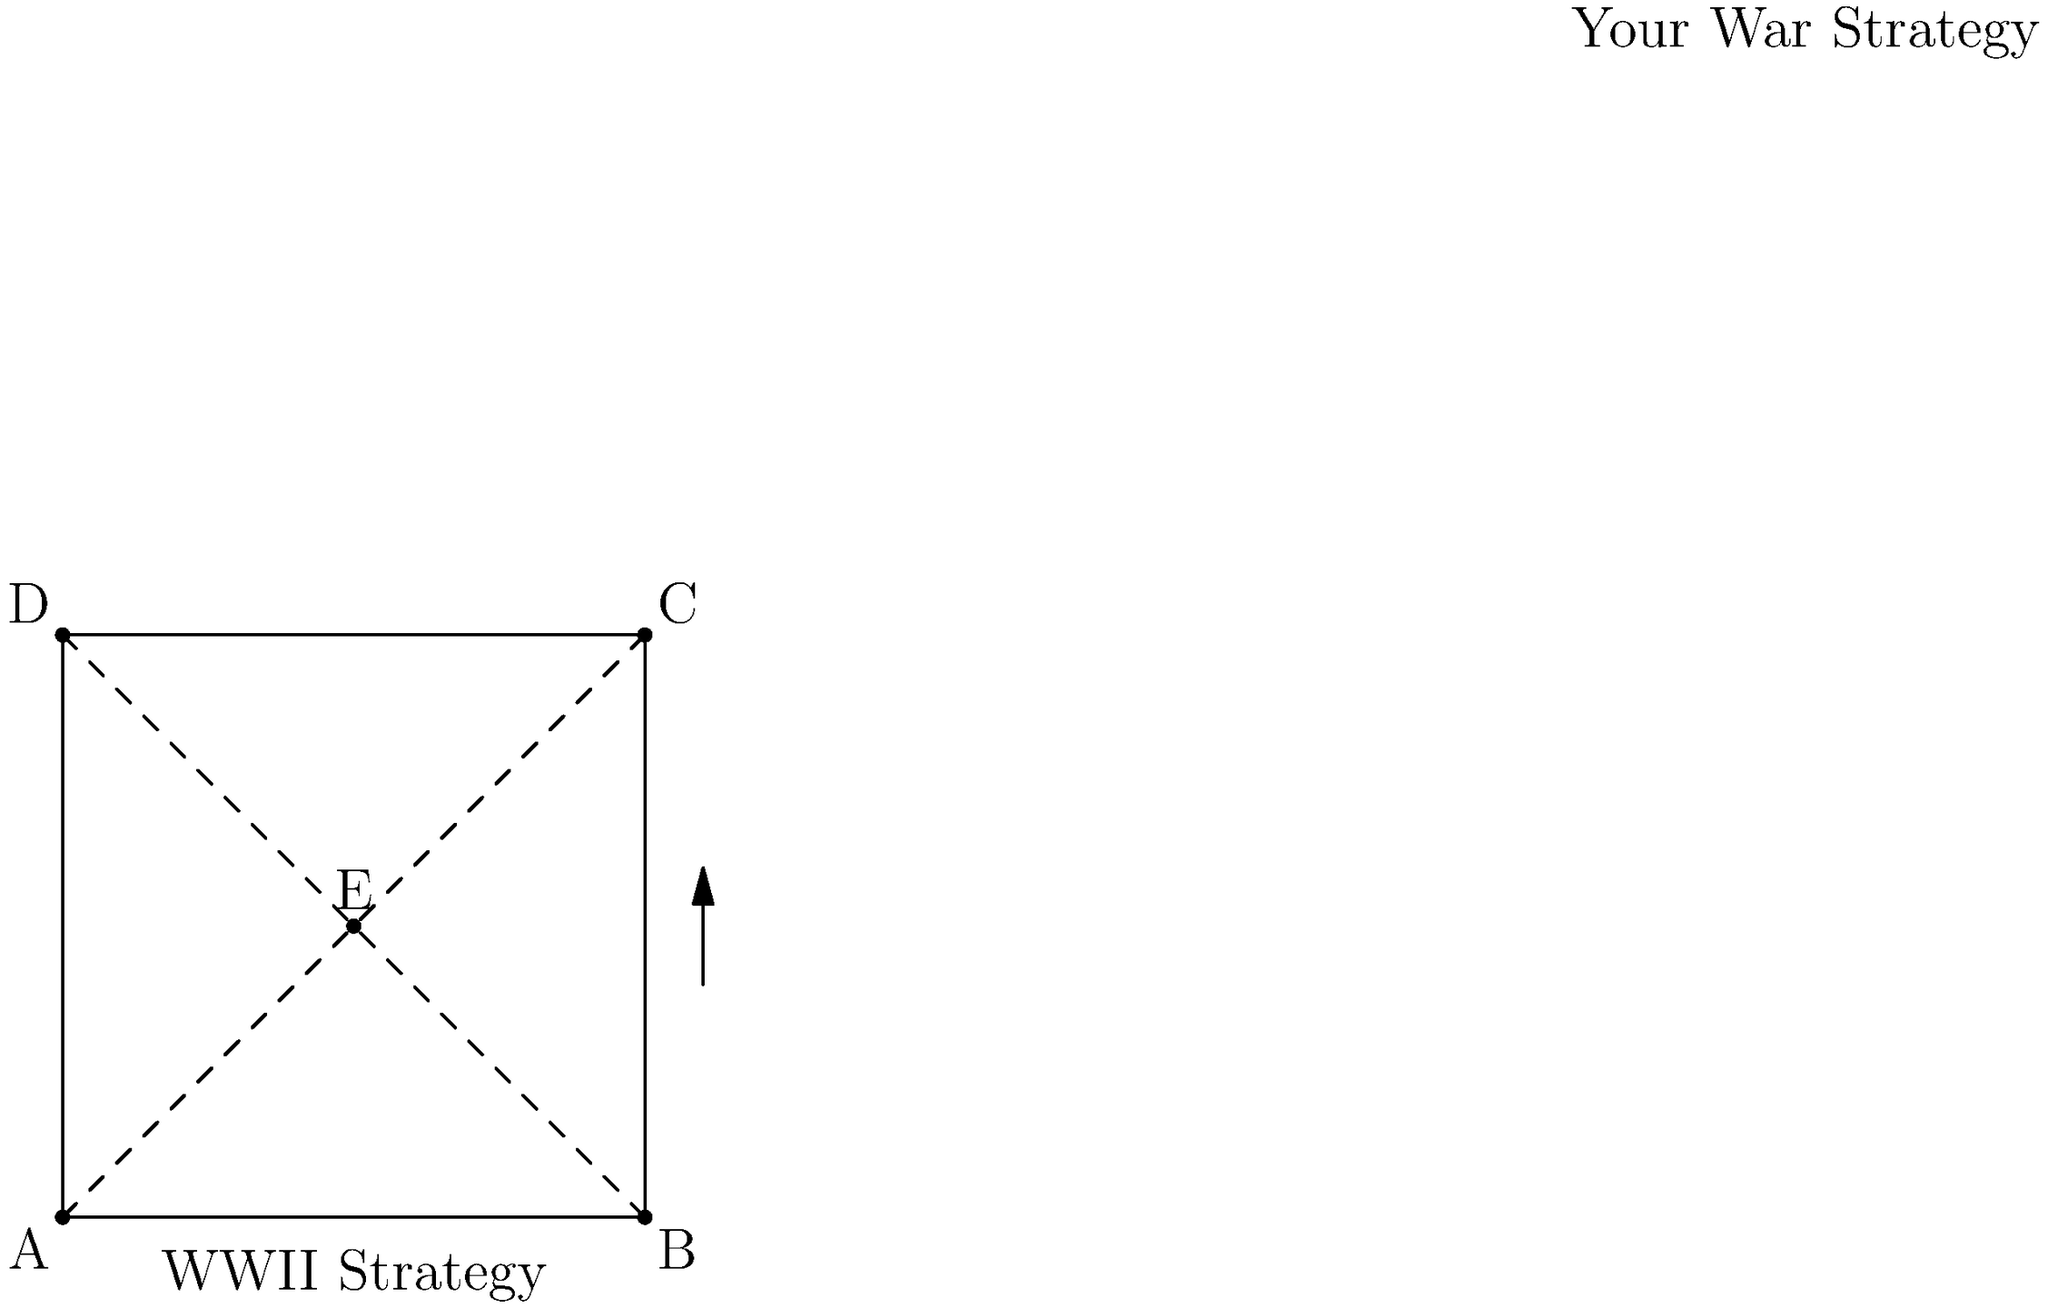Analyze the tactical map shown above, which compares a WWII pincer movement strategy (represented by the square ABCD) with a centralized assault strategy from your war (represented by point E). How would the effectiveness of these two strategies differ in terms of troop concentration and potential for enemy encirclement? Provide a quantitative assessment using the concept of distance from the center point to the corners. To compare the effectiveness of these two strategies, we'll analyze them step-by-step:

1. WWII Pincer Movement (Square ABCD):
   - This strategy involves attacking from multiple directions to encircle the enemy.
   - The diagonal distance from the center to any corner represents the maximum spread of forces.
   - Using the Pythagorean theorem, this distance is:
     $$d_{pincer} = \sqrt{(\frac{100}{2})^2 + (\frac{100}{2})^2} = 50\sqrt{2} \approx 70.71$$

2. Centralized Assault (Point E):
   - This strategy concentrates forces at a single point for a focused attack.
   - The distance from E to any corner is the same as the pincer movement's diagonal:
     $$d_{central} = 50\sqrt{2} \approx 70.71$$

3. Troop Concentration:
   - Pincer Movement: Forces are spread across four points, so concentration at each point is 25% of total forces.
   - Centralized Assault: All forces (100%) are concentrated at a single point.

4. Potential for Encirclement:
   - Pincer Movement: High potential, as forces can attack from multiple directions.
   - Centralized Assault: Lower potential, as all forces are coming from one direction.

5. Flexibility:
   - Pincer Movement: More flexible, can adapt to changing battlefield conditions.
   - Centralized Assault: Less flexible, but potentially more powerful at the point of attack.

6. Risk:
   - Pincer Movement: Lower risk, as forces are distributed.
   - Centralized Assault: Higher risk, as all forces are vulnerable to a single counterattack.

7. Quantitative Comparison:
   - Force Concentration Ratio = Central / Pincer = 100% / 25% = 4
   - This means the centralized assault has 4 times the force concentration at the point of attack.

The effectiveness of each strategy would depend on specific battlefield conditions, enemy positioning, and available resources. The pincer movement offers better encirclement potential and flexibility, while the centralized assault provides superior force concentration at a single point.
Answer: Centralized assault offers 4x force concentration but less encirclement potential; pincer movement provides better flexibility and lower risk. 